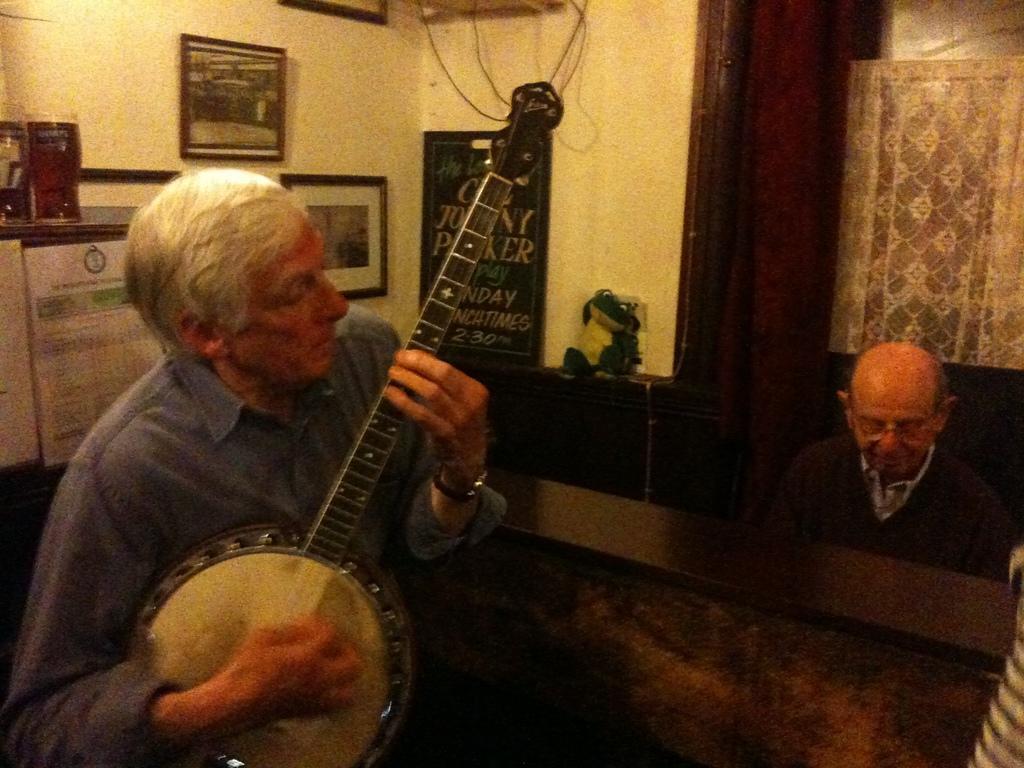Describe this image in one or two sentences. In the picture we can see two people. One person is holding a guitar and other is sitting. In the background we can see a wall, photo frames, calendar, board. 